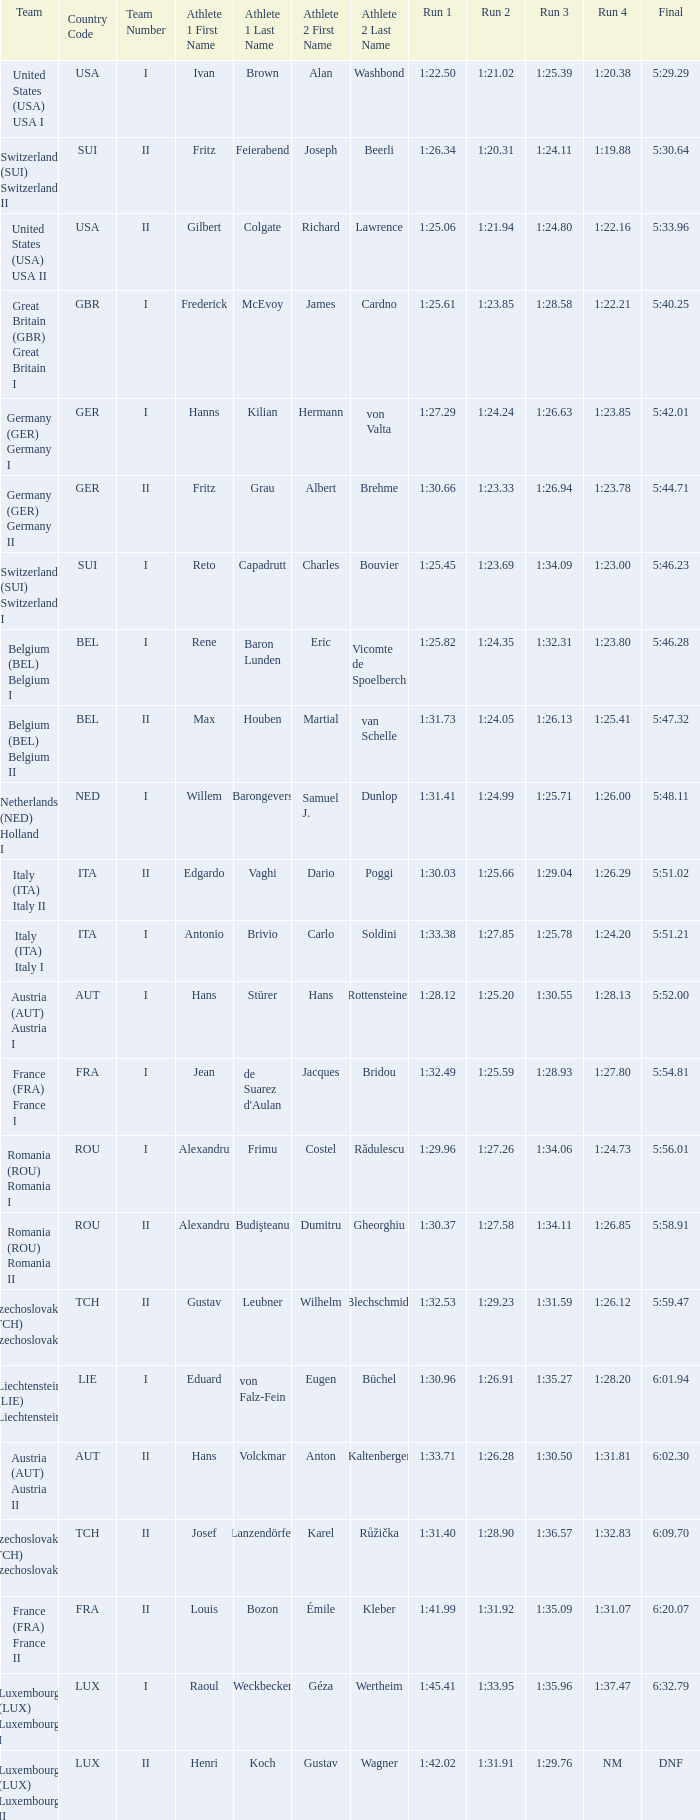In which final event is there a run 2 with a duration of 1:2 5:58.91. 